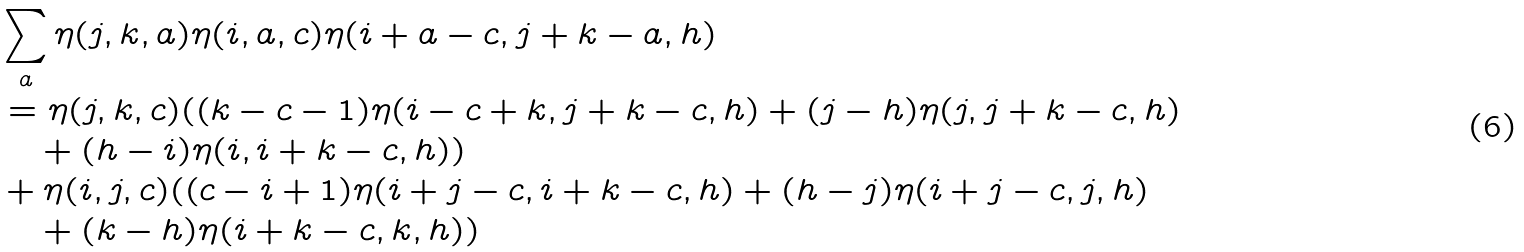<formula> <loc_0><loc_0><loc_500><loc_500>& \sum _ { a } \eta ( j , k , a ) \eta ( i , a , c ) \eta ( i + a - c , j + k - a , h ) \\ & = \eta ( j , k , c ) ( ( k - c - 1 ) \eta ( i - c + k , j + k - c , h ) + ( j - h ) \eta ( j , j + k - c , h ) \\ & \quad + ( h - i ) \eta ( i , i + k - c , h ) ) \\ & + \eta ( i , j , c ) ( ( c - i + 1 ) \eta ( i + j - c , i + k - c , h ) + ( h - j ) \eta ( i + j - c , j , h ) \\ & \quad + ( k - h ) \eta ( i + k - c , k , h ) )</formula> 